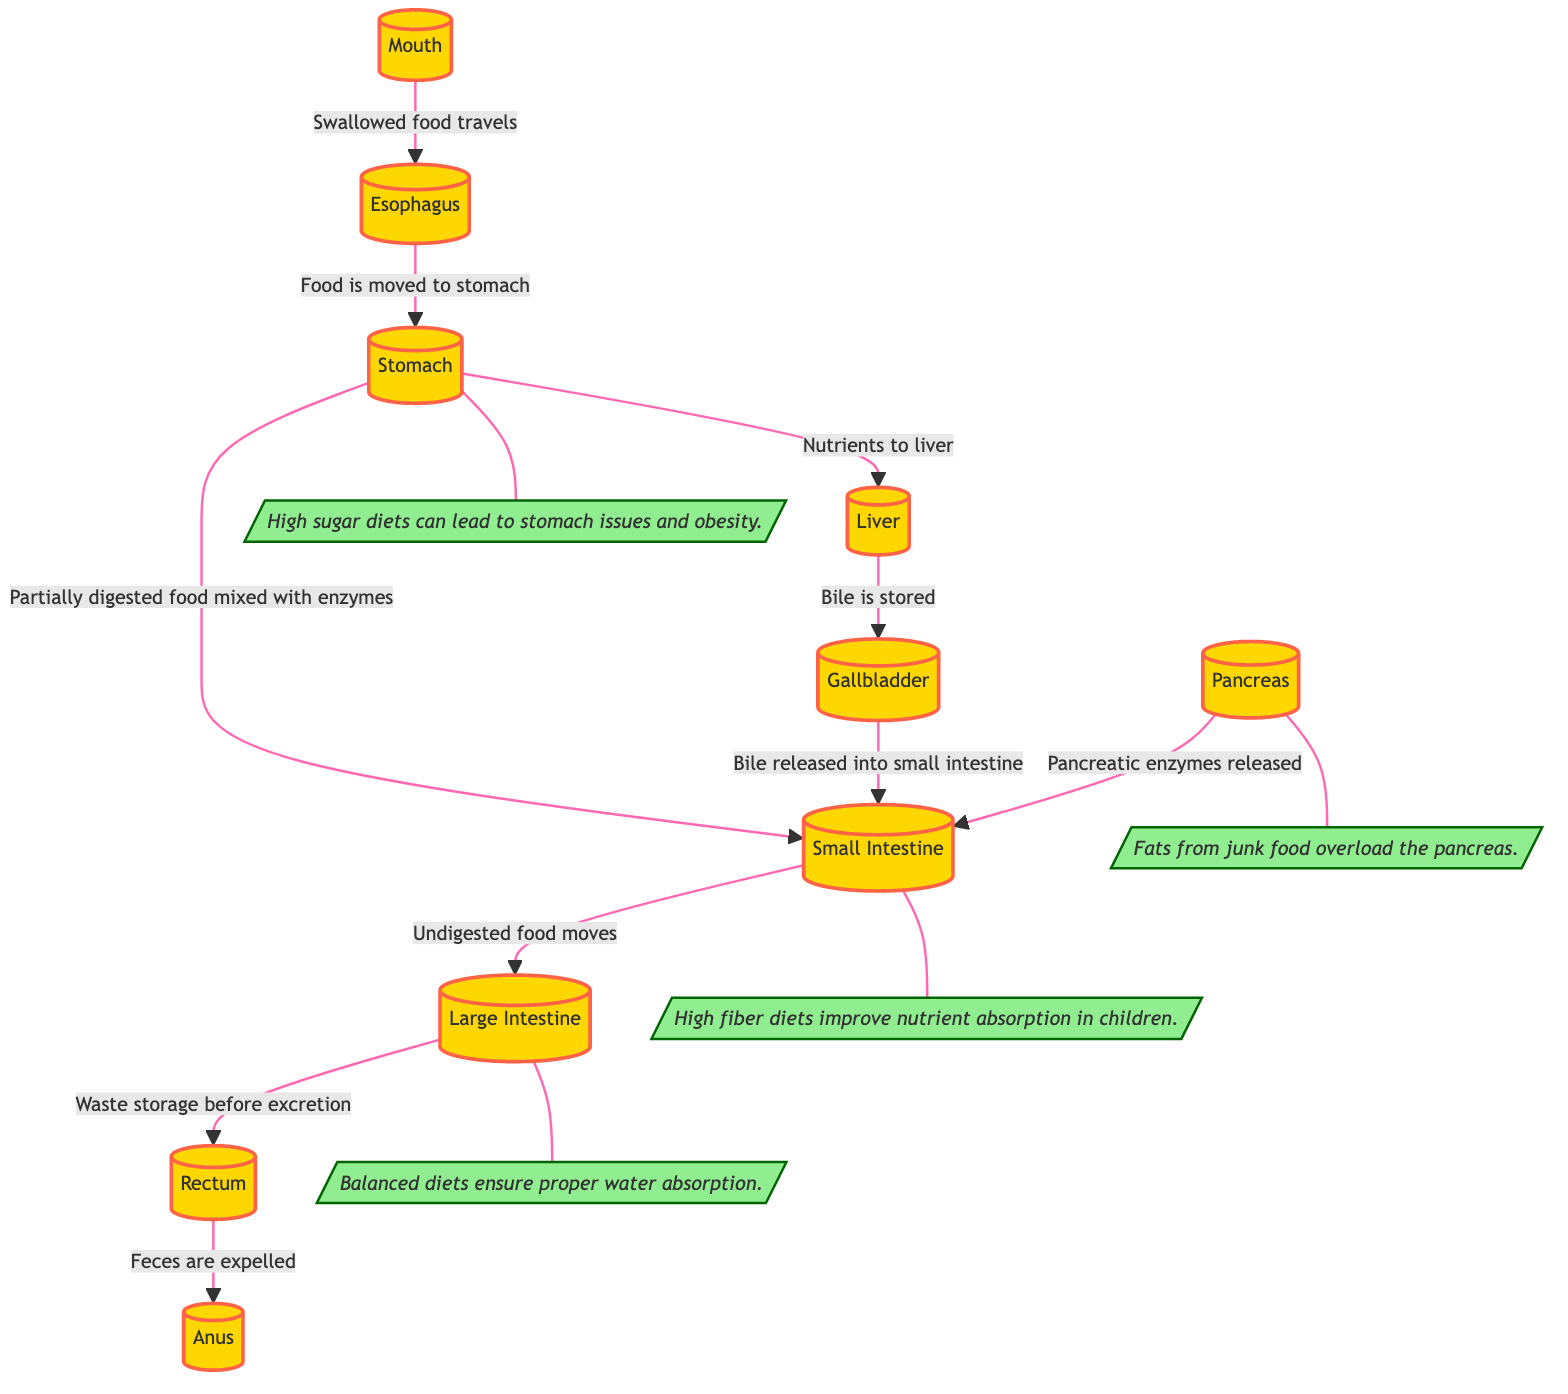What is the first organ in the digestive process? The diagram starts with the "Mouth," which is the first organ where food enters the digestive system.
Answer: Mouth Which organ is responsible for storing bile? According to the diagram, the "Gallbladder" is the organ that stores bile before it is released into the small intestine.
Answer: Gallbladder How many organs are involved in the digestive system as shown in this diagram? The diagram lists a total of 10 organs, including the mouth, esophagus, stomach, liver, gallbladder, pancreas, small intestine, large intestine, rectum, and anus.
Answer: 10 What dietary effect is associated with the small intestine in the diagram? The annotation connected to the small intestine states that "High fiber diets improve nutrient absorption in children," indicating that fiber-rich diets enhance the functionality of this organ.
Answer: High fiber diets improve nutrient absorption What is released into the small intestine from the pancreas? The diagram indicates that "Pancreatic enzymes released" from the pancreas facilitate the digestion process in the small intestine, contributing to the breakdown of food components.
Answer: Pancreatic enzymes Which organ receives nutrients after food is partially digested? The diagram shows that after food is mixed with enzymes in the stomach, the nutrient-rich substance is transported to the "Liver" for further processing.
Answer: Liver What can high sugar diets lead to according to this diagram? The annotation associated with the stomach mentions that "High sugar diets can lead to stomach issues and obesity," implying negative health effects related to high sugar consumption.
Answer: Stomach issues and obesity What happens to undigested food in the digestive system? According to the diagram, undigested food moves from the small intestine to the "Large Intestine," where it is stored before excretion, highlighting the final stages of digestion.
Answer: Waste storage before excretion How does fat from junk food affect the pancreas? An annotation explains that "Fats from junk food overload the pancreas," indicating a potential health risk associated with high-fat diets, particularly from unhealthy sources.
Answer: Overload the pancreas What is the final step in the digestive process as indicated in the diagram? The diagram concludes with the process of "Feces are expelled," showing that the final step of the digestive process is the elimination of undigested waste through the anus.
Answer: Feces are expelled 